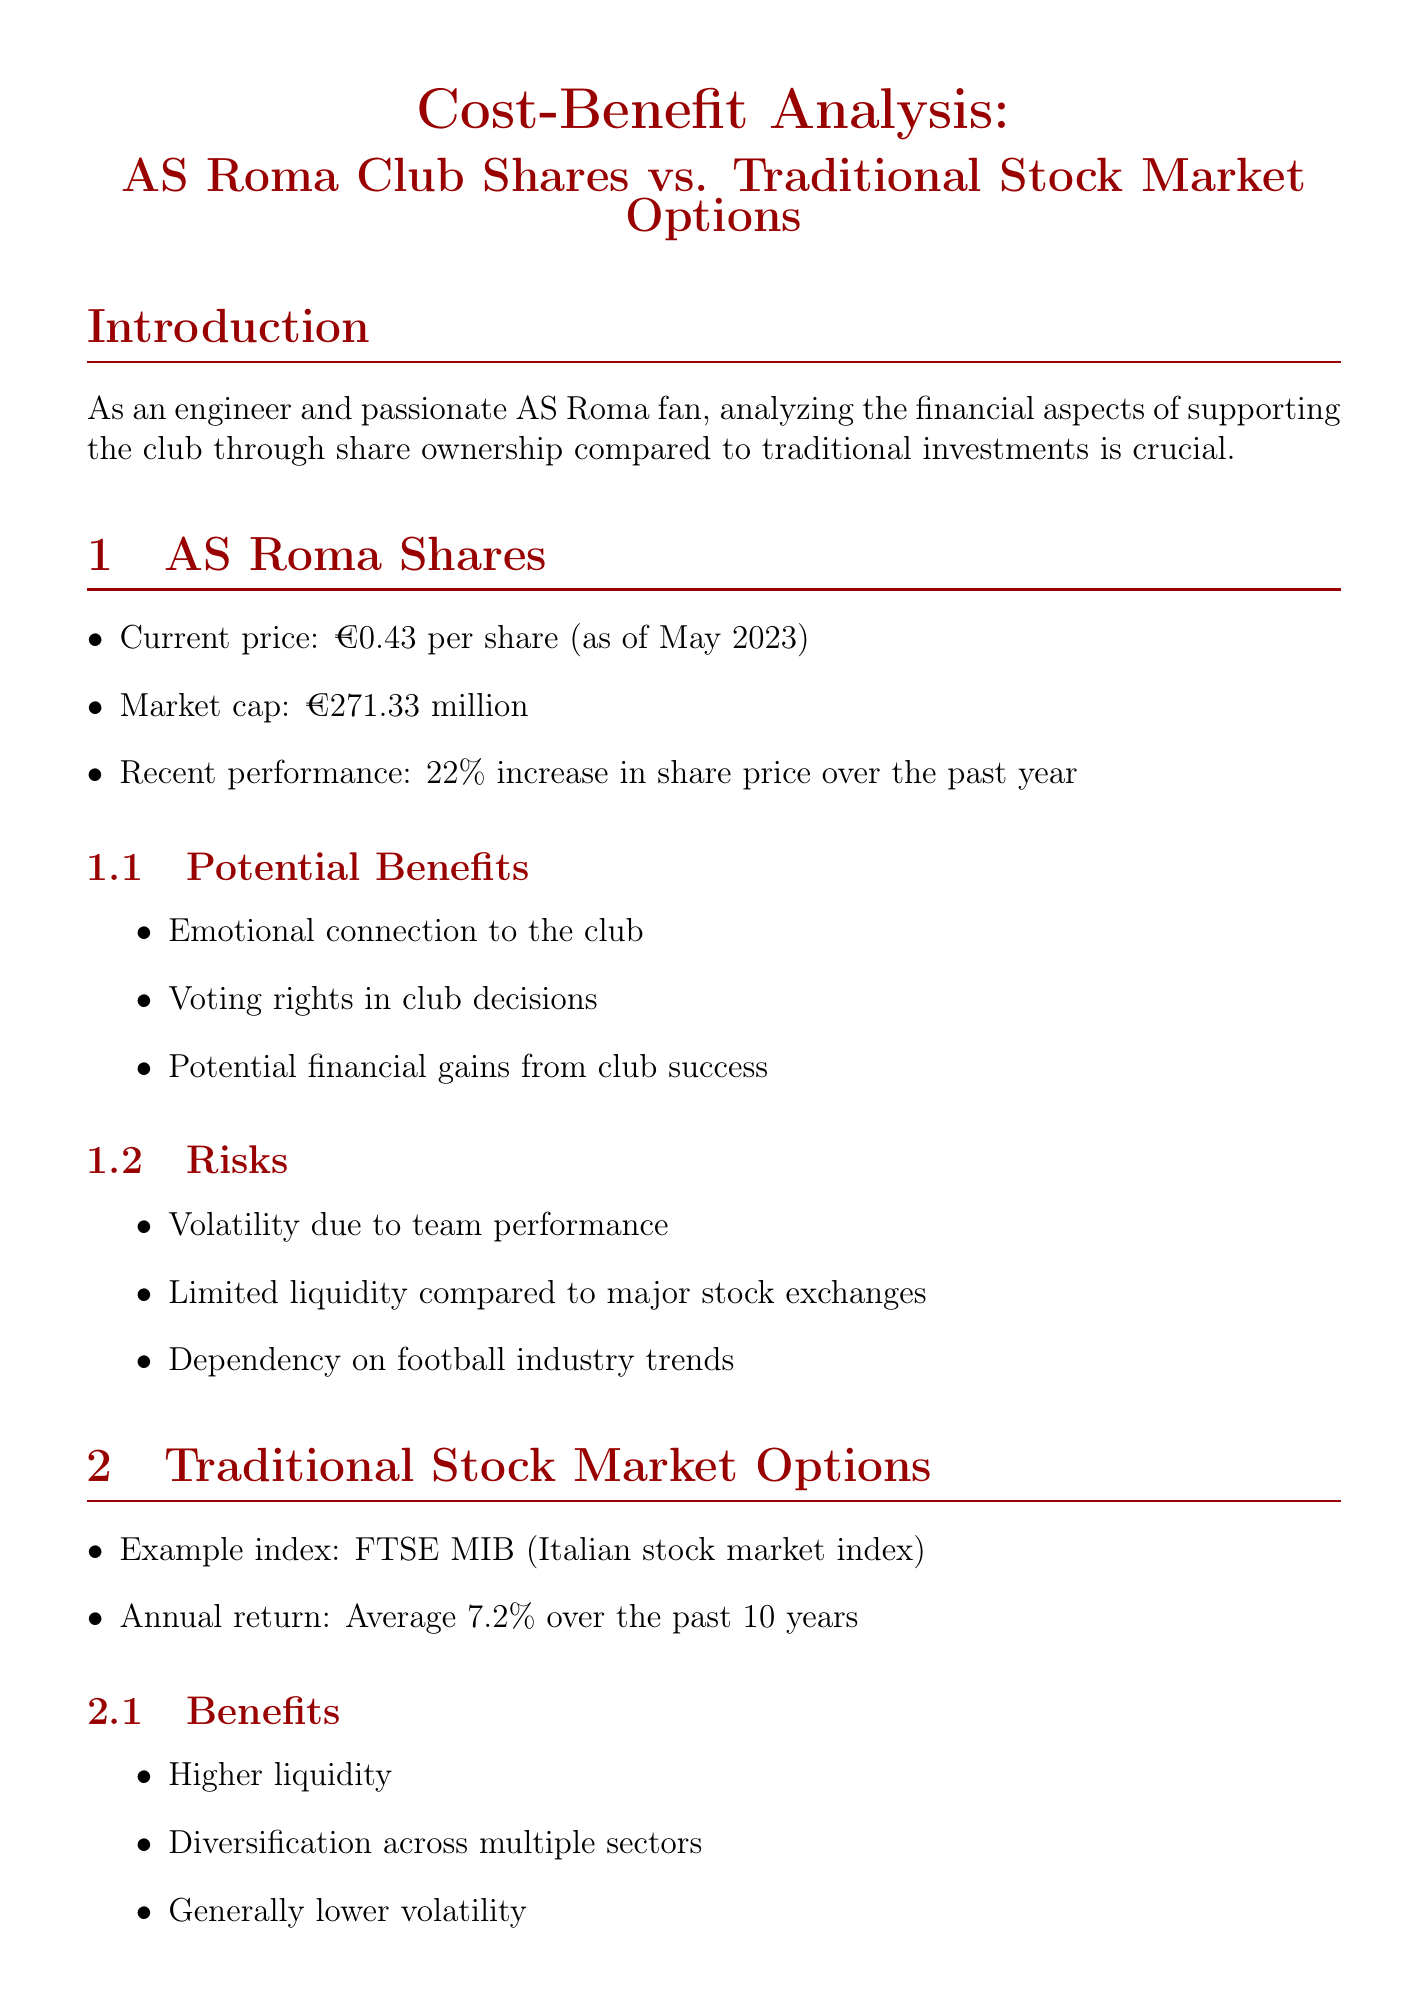What is the current price of AS Roma shares? The current price is stated clearly in the document as €0.43 per share (as of May 2023).
Answer: €0.43 What is the recent performance percentage of AS Roma shares? The document mentions a 22% increase in share price over the past year.
Answer: 22% What is the projected annual return for AS Roma shares? The document states that the projected annual return is 15% annually in the optimistic scenario.
Answer: 15% What is the average annual return for the FTSE MIB over the past 10 years? The document specifies this average annual return as 7.2%.
Answer: 7.2% What is the market capitalization of AS Roma? The market cap is indicated in the document as €271.33 million.
Answer: €271.33 million What are the potential financial gains associated with AS Roma shares? The document lists potential financial gains from club success as a benefit of AS Roma shares.
Answer: Potential financial gains from club success Which investment option offers higher liquidity? The document compares liquidity and states that traditional stock market options provide higher liquidity.
Answer: Traditional stock market options What year is the data regarding AS Roma shares based on? The document specifies the date for the current price as May 2023.
Answer: May 2023 What is the 5-year projection for investment in AS Roma shares? The financial comparison section provides the 5-year projection as €20,113.57.
Answer: €20,113.57 What influences the decision-making regarding investing in AS Roma shares according to the conclusion? The conclusion highlights that personal passion for AS Roma may influence decision-making beyond financial considerations.
Answer: Personal passion for AS Roma 